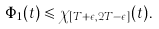<formula> <loc_0><loc_0><loc_500><loc_500>\Phi _ { 1 } ( t ) \leqslant \chi _ { [ T + \epsilon , 2 T - \epsilon ] } ( t ) .</formula> 